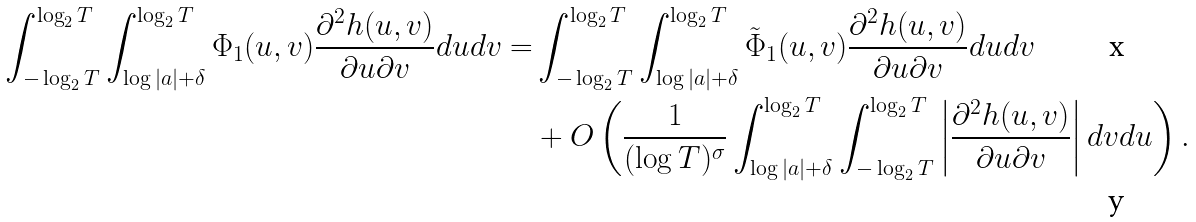Convert formula to latex. <formula><loc_0><loc_0><loc_500><loc_500>\int _ { - \log _ { 2 } T } ^ { \log _ { 2 } T } \int _ { \log | a | + \delta } ^ { \log _ { 2 } T } \Phi _ { 1 } ( u , v ) \frac { \partial ^ { 2 } h ( u , v ) } { \partial u \partial v } d u d v = & \int _ { - \log _ { 2 } T } ^ { \log _ { 2 } T } \int _ { \log | a | + \delta } ^ { \log _ { 2 } T } \tilde { \Phi } _ { 1 } ( u , v ) \frac { \partial ^ { 2 } h ( u , v ) } { \partial u \partial v } d u d v \\ & + O \left ( \frac { 1 } { ( \log T ) ^ { \sigma } } \int _ { \log | a | + \delta } ^ { \log _ { 2 } T } \int _ { - \log _ { 2 } T } ^ { \log _ { 2 } T } \left | \frac { \partial ^ { 2 } h ( u , v ) } { \partial u \partial v } \right | d v d u \right ) .</formula> 